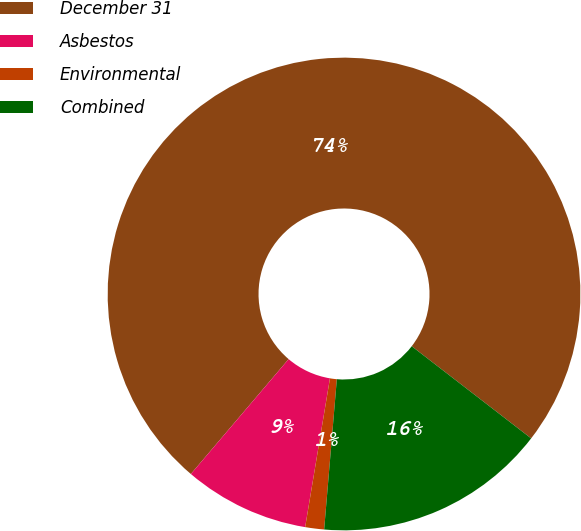<chart> <loc_0><loc_0><loc_500><loc_500><pie_chart><fcel>December 31<fcel>Asbestos<fcel>Environmental<fcel>Combined<nl><fcel>74.24%<fcel>8.59%<fcel>1.29%<fcel>15.88%<nl></chart> 